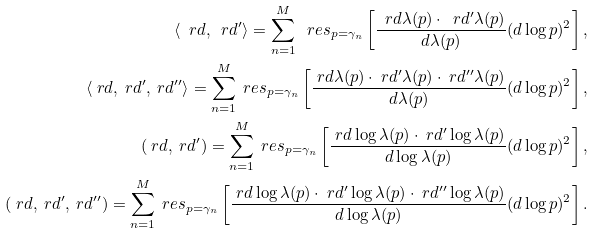Convert formula to latex. <formula><loc_0><loc_0><loc_500><loc_500>\langle \ r d , \ r d ^ { \prime } \rangle = \sum _ { n = 1 } ^ { M } \ r e s _ { p = \gamma _ { n } } \left [ \frac { \ r d \lambda ( p ) \cdot \ r d ^ { \prime } \lambda ( p ) } { d \lambda ( p ) } ( d \log p ) ^ { 2 } \right ] , \\ \langle \ r d , \ r d ^ { \prime } , \ r d ^ { \prime \prime } \rangle = \sum _ { n = 1 } ^ { M } \ r e s _ { p = \gamma _ { n } } \left [ \frac { \ r d \lambda ( p ) \cdot \ r d ^ { \prime } \lambda ( p ) \cdot \ r d ^ { \prime \prime } \lambda ( p ) } { d \lambda ( p ) } ( d \log p ) ^ { 2 } \right ] , \\ ( \ r d , \ r d ^ { \prime } ) = \sum _ { n = 1 } ^ { M } \ r e s _ { p = \gamma _ { n } } \left [ \frac { \ r d \log \lambda ( p ) \cdot \ r d ^ { \prime } \log \lambda ( p ) } { d \log \lambda ( p ) } ( d \log p ) ^ { 2 } \right ] , \\ ( \ r d , \ r d ^ { \prime } , \ r d ^ { \prime \prime } ) = \sum _ { n = 1 } ^ { M } \ r e s _ { p = \gamma _ { n } } \left [ \frac { \ r d \log \lambda ( p ) \cdot \ r d ^ { \prime } \log \lambda ( p ) \cdot \ r d ^ { \prime \prime } \log \lambda ( p ) } { d \log \lambda ( p ) } ( d \log p ) ^ { 2 } \right ] .</formula> 